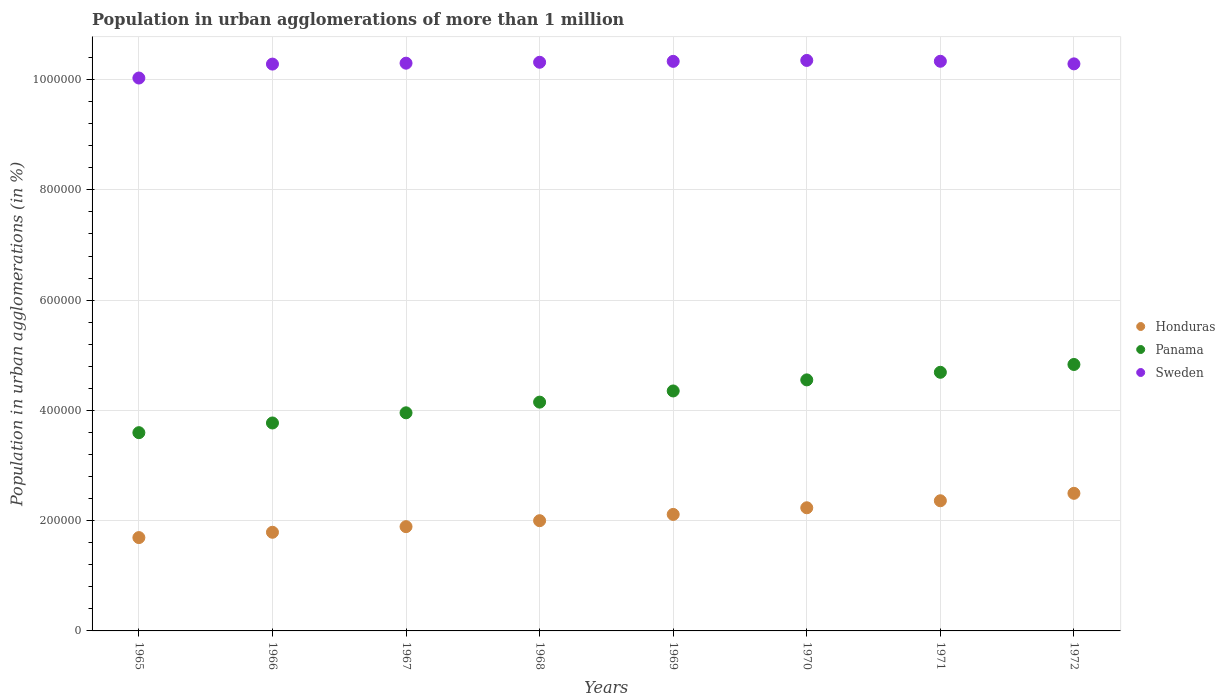What is the population in urban agglomerations in Sweden in 1967?
Offer a very short reply. 1.03e+06. Across all years, what is the maximum population in urban agglomerations in Honduras?
Your answer should be very brief. 2.50e+05. Across all years, what is the minimum population in urban agglomerations in Sweden?
Offer a very short reply. 1.00e+06. In which year was the population in urban agglomerations in Honduras minimum?
Give a very brief answer. 1965. What is the total population in urban agglomerations in Honduras in the graph?
Provide a succinct answer. 1.66e+06. What is the difference between the population in urban agglomerations in Sweden in 1965 and that in 1972?
Your answer should be compact. -2.57e+04. What is the difference between the population in urban agglomerations in Panama in 1969 and the population in urban agglomerations in Honduras in 1968?
Make the answer very short. 2.35e+05. What is the average population in urban agglomerations in Sweden per year?
Offer a terse response. 1.03e+06. In the year 1972, what is the difference between the population in urban agglomerations in Sweden and population in urban agglomerations in Panama?
Ensure brevity in your answer.  5.45e+05. In how many years, is the population in urban agglomerations in Honduras greater than 120000 %?
Provide a short and direct response. 8. What is the ratio of the population in urban agglomerations in Sweden in 1966 to that in 1970?
Make the answer very short. 0.99. Is the population in urban agglomerations in Sweden in 1970 less than that in 1971?
Your answer should be very brief. No. What is the difference between the highest and the second highest population in urban agglomerations in Panama?
Your answer should be very brief. 1.42e+04. What is the difference between the highest and the lowest population in urban agglomerations in Sweden?
Provide a short and direct response. 3.19e+04. Is the sum of the population in urban agglomerations in Honduras in 1967 and 1971 greater than the maximum population in urban agglomerations in Sweden across all years?
Your answer should be compact. No. Is it the case that in every year, the sum of the population in urban agglomerations in Sweden and population in urban agglomerations in Panama  is greater than the population in urban agglomerations in Honduras?
Give a very brief answer. Yes. Is the population in urban agglomerations in Honduras strictly greater than the population in urban agglomerations in Panama over the years?
Your answer should be compact. No. Is the population in urban agglomerations in Panama strictly less than the population in urban agglomerations in Sweden over the years?
Offer a terse response. Yes. What is the difference between two consecutive major ticks on the Y-axis?
Your response must be concise. 2.00e+05. Does the graph contain grids?
Ensure brevity in your answer.  Yes. Where does the legend appear in the graph?
Your response must be concise. Center right. How many legend labels are there?
Keep it short and to the point. 3. How are the legend labels stacked?
Provide a succinct answer. Vertical. What is the title of the graph?
Ensure brevity in your answer.  Population in urban agglomerations of more than 1 million. What is the label or title of the Y-axis?
Ensure brevity in your answer.  Population in urban agglomerations (in %). What is the Population in urban agglomerations (in %) of Honduras in 1965?
Make the answer very short. 1.69e+05. What is the Population in urban agglomerations (in %) in Panama in 1965?
Give a very brief answer. 3.60e+05. What is the Population in urban agglomerations (in %) in Sweden in 1965?
Offer a terse response. 1.00e+06. What is the Population in urban agglomerations (in %) of Honduras in 1966?
Ensure brevity in your answer.  1.79e+05. What is the Population in urban agglomerations (in %) of Panama in 1966?
Offer a terse response. 3.77e+05. What is the Population in urban agglomerations (in %) in Sweden in 1966?
Your answer should be very brief. 1.03e+06. What is the Population in urban agglomerations (in %) of Honduras in 1967?
Give a very brief answer. 1.89e+05. What is the Population in urban agglomerations (in %) of Panama in 1967?
Keep it short and to the point. 3.96e+05. What is the Population in urban agglomerations (in %) in Sweden in 1967?
Your answer should be compact. 1.03e+06. What is the Population in urban agglomerations (in %) in Honduras in 1968?
Give a very brief answer. 2.00e+05. What is the Population in urban agglomerations (in %) in Panama in 1968?
Provide a succinct answer. 4.15e+05. What is the Population in urban agglomerations (in %) in Sweden in 1968?
Provide a short and direct response. 1.03e+06. What is the Population in urban agglomerations (in %) in Honduras in 1969?
Your response must be concise. 2.11e+05. What is the Population in urban agglomerations (in %) in Panama in 1969?
Make the answer very short. 4.35e+05. What is the Population in urban agglomerations (in %) of Sweden in 1969?
Offer a very short reply. 1.03e+06. What is the Population in urban agglomerations (in %) of Honduras in 1970?
Ensure brevity in your answer.  2.23e+05. What is the Population in urban agglomerations (in %) of Panama in 1970?
Offer a terse response. 4.55e+05. What is the Population in urban agglomerations (in %) in Sweden in 1970?
Keep it short and to the point. 1.03e+06. What is the Population in urban agglomerations (in %) of Honduras in 1971?
Keep it short and to the point. 2.36e+05. What is the Population in urban agglomerations (in %) in Panama in 1971?
Give a very brief answer. 4.69e+05. What is the Population in urban agglomerations (in %) of Sweden in 1971?
Your response must be concise. 1.03e+06. What is the Population in urban agglomerations (in %) of Honduras in 1972?
Give a very brief answer. 2.50e+05. What is the Population in urban agglomerations (in %) in Panama in 1972?
Keep it short and to the point. 4.83e+05. What is the Population in urban agglomerations (in %) in Sweden in 1972?
Your answer should be very brief. 1.03e+06. Across all years, what is the maximum Population in urban agglomerations (in %) in Honduras?
Keep it short and to the point. 2.50e+05. Across all years, what is the maximum Population in urban agglomerations (in %) in Panama?
Your answer should be compact. 4.83e+05. Across all years, what is the maximum Population in urban agglomerations (in %) in Sweden?
Ensure brevity in your answer.  1.03e+06. Across all years, what is the minimum Population in urban agglomerations (in %) in Honduras?
Your response must be concise. 1.69e+05. Across all years, what is the minimum Population in urban agglomerations (in %) of Panama?
Offer a terse response. 3.60e+05. Across all years, what is the minimum Population in urban agglomerations (in %) in Sweden?
Offer a terse response. 1.00e+06. What is the total Population in urban agglomerations (in %) in Honduras in the graph?
Provide a short and direct response. 1.66e+06. What is the total Population in urban agglomerations (in %) of Panama in the graph?
Offer a terse response. 3.39e+06. What is the total Population in urban agglomerations (in %) of Sweden in the graph?
Your answer should be very brief. 8.22e+06. What is the difference between the Population in urban agglomerations (in %) of Honduras in 1965 and that in 1966?
Make the answer very short. -9649. What is the difference between the Population in urban agglomerations (in %) of Panama in 1965 and that in 1966?
Your answer should be compact. -1.76e+04. What is the difference between the Population in urban agglomerations (in %) of Sweden in 1965 and that in 1966?
Provide a short and direct response. -2.53e+04. What is the difference between the Population in urban agglomerations (in %) in Honduras in 1965 and that in 1967?
Make the answer very short. -1.98e+04. What is the difference between the Population in urban agglomerations (in %) in Panama in 1965 and that in 1967?
Your response must be concise. -3.60e+04. What is the difference between the Population in urban agglomerations (in %) of Sweden in 1965 and that in 1967?
Make the answer very short. -2.69e+04. What is the difference between the Population in urban agglomerations (in %) of Honduras in 1965 and that in 1968?
Your answer should be very brief. -3.06e+04. What is the difference between the Population in urban agglomerations (in %) in Panama in 1965 and that in 1968?
Offer a terse response. -5.54e+04. What is the difference between the Population in urban agglomerations (in %) of Sweden in 1965 and that in 1968?
Your answer should be very brief. -2.86e+04. What is the difference between the Population in urban agglomerations (in %) of Honduras in 1965 and that in 1969?
Your response must be concise. -4.20e+04. What is the difference between the Population in urban agglomerations (in %) of Panama in 1965 and that in 1969?
Your answer should be very brief. -7.57e+04. What is the difference between the Population in urban agglomerations (in %) in Sweden in 1965 and that in 1969?
Keep it short and to the point. -3.02e+04. What is the difference between the Population in urban agglomerations (in %) in Honduras in 1965 and that in 1970?
Offer a very short reply. -5.41e+04. What is the difference between the Population in urban agglomerations (in %) of Panama in 1965 and that in 1970?
Keep it short and to the point. -9.58e+04. What is the difference between the Population in urban agglomerations (in %) in Sweden in 1965 and that in 1970?
Offer a terse response. -3.19e+04. What is the difference between the Population in urban agglomerations (in %) in Honduras in 1965 and that in 1971?
Provide a succinct answer. -6.68e+04. What is the difference between the Population in urban agglomerations (in %) in Panama in 1965 and that in 1971?
Provide a short and direct response. -1.10e+05. What is the difference between the Population in urban agglomerations (in %) of Sweden in 1965 and that in 1971?
Your answer should be very brief. -3.04e+04. What is the difference between the Population in urban agglomerations (in %) in Honduras in 1965 and that in 1972?
Your response must be concise. -8.03e+04. What is the difference between the Population in urban agglomerations (in %) in Panama in 1965 and that in 1972?
Make the answer very short. -1.24e+05. What is the difference between the Population in urban agglomerations (in %) of Sweden in 1965 and that in 1972?
Provide a succinct answer. -2.57e+04. What is the difference between the Population in urban agglomerations (in %) of Honduras in 1966 and that in 1967?
Make the answer very short. -1.02e+04. What is the difference between the Population in urban agglomerations (in %) of Panama in 1966 and that in 1967?
Your answer should be very brief. -1.84e+04. What is the difference between the Population in urban agglomerations (in %) of Sweden in 1966 and that in 1967?
Give a very brief answer. -1655. What is the difference between the Population in urban agglomerations (in %) in Honduras in 1966 and that in 1968?
Offer a very short reply. -2.10e+04. What is the difference between the Population in urban agglomerations (in %) of Panama in 1966 and that in 1968?
Offer a terse response. -3.78e+04. What is the difference between the Population in urban agglomerations (in %) in Sweden in 1966 and that in 1968?
Make the answer very short. -3316. What is the difference between the Population in urban agglomerations (in %) in Honduras in 1966 and that in 1969?
Make the answer very short. -3.24e+04. What is the difference between the Population in urban agglomerations (in %) in Panama in 1966 and that in 1969?
Make the answer very short. -5.81e+04. What is the difference between the Population in urban agglomerations (in %) of Sweden in 1966 and that in 1969?
Ensure brevity in your answer.  -4974. What is the difference between the Population in urban agglomerations (in %) in Honduras in 1966 and that in 1970?
Provide a succinct answer. -4.44e+04. What is the difference between the Population in urban agglomerations (in %) of Panama in 1966 and that in 1970?
Offer a very short reply. -7.82e+04. What is the difference between the Population in urban agglomerations (in %) in Sweden in 1966 and that in 1970?
Your answer should be compact. -6638. What is the difference between the Population in urban agglomerations (in %) in Honduras in 1966 and that in 1971?
Keep it short and to the point. -5.72e+04. What is the difference between the Population in urban agglomerations (in %) of Panama in 1966 and that in 1971?
Give a very brief answer. -9.19e+04. What is the difference between the Population in urban agglomerations (in %) of Sweden in 1966 and that in 1971?
Provide a succinct answer. -5123. What is the difference between the Population in urban agglomerations (in %) of Honduras in 1966 and that in 1972?
Your response must be concise. -7.06e+04. What is the difference between the Population in urban agglomerations (in %) in Panama in 1966 and that in 1972?
Provide a short and direct response. -1.06e+05. What is the difference between the Population in urban agglomerations (in %) of Sweden in 1966 and that in 1972?
Provide a short and direct response. -418. What is the difference between the Population in urban agglomerations (in %) in Honduras in 1967 and that in 1968?
Provide a succinct answer. -1.08e+04. What is the difference between the Population in urban agglomerations (in %) in Panama in 1967 and that in 1968?
Offer a terse response. -1.94e+04. What is the difference between the Population in urban agglomerations (in %) in Sweden in 1967 and that in 1968?
Make the answer very short. -1661. What is the difference between the Population in urban agglomerations (in %) in Honduras in 1967 and that in 1969?
Offer a very short reply. -2.22e+04. What is the difference between the Population in urban agglomerations (in %) of Panama in 1967 and that in 1969?
Provide a short and direct response. -3.96e+04. What is the difference between the Population in urban agglomerations (in %) in Sweden in 1967 and that in 1969?
Ensure brevity in your answer.  -3319. What is the difference between the Population in urban agglomerations (in %) of Honduras in 1967 and that in 1970?
Your answer should be very brief. -3.42e+04. What is the difference between the Population in urban agglomerations (in %) in Panama in 1967 and that in 1970?
Keep it short and to the point. -5.97e+04. What is the difference between the Population in urban agglomerations (in %) of Sweden in 1967 and that in 1970?
Your response must be concise. -4983. What is the difference between the Population in urban agglomerations (in %) in Honduras in 1967 and that in 1971?
Your response must be concise. -4.70e+04. What is the difference between the Population in urban agglomerations (in %) in Panama in 1967 and that in 1971?
Provide a succinct answer. -7.35e+04. What is the difference between the Population in urban agglomerations (in %) in Sweden in 1967 and that in 1971?
Offer a very short reply. -3468. What is the difference between the Population in urban agglomerations (in %) of Honduras in 1967 and that in 1972?
Offer a very short reply. -6.04e+04. What is the difference between the Population in urban agglomerations (in %) in Panama in 1967 and that in 1972?
Provide a succinct answer. -8.77e+04. What is the difference between the Population in urban agglomerations (in %) of Sweden in 1967 and that in 1972?
Ensure brevity in your answer.  1237. What is the difference between the Population in urban agglomerations (in %) of Honduras in 1968 and that in 1969?
Give a very brief answer. -1.14e+04. What is the difference between the Population in urban agglomerations (in %) in Panama in 1968 and that in 1969?
Offer a very short reply. -2.03e+04. What is the difference between the Population in urban agglomerations (in %) in Sweden in 1968 and that in 1969?
Your response must be concise. -1658. What is the difference between the Population in urban agglomerations (in %) of Honduras in 1968 and that in 1970?
Ensure brevity in your answer.  -2.34e+04. What is the difference between the Population in urban agglomerations (in %) in Panama in 1968 and that in 1970?
Provide a succinct answer. -4.04e+04. What is the difference between the Population in urban agglomerations (in %) of Sweden in 1968 and that in 1970?
Make the answer very short. -3322. What is the difference between the Population in urban agglomerations (in %) in Honduras in 1968 and that in 1971?
Offer a terse response. -3.62e+04. What is the difference between the Population in urban agglomerations (in %) of Panama in 1968 and that in 1971?
Keep it short and to the point. -5.41e+04. What is the difference between the Population in urban agglomerations (in %) in Sweden in 1968 and that in 1971?
Give a very brief answer. -1807. What is the difference between the Population in urban agglomerations (in %) in Honduras in 1968 and that in 1972?
Give a very brief answer. -4.96e+04. What is the difference between the Population in urban agglomerations (in %) of Panama in 1968 and that in 1972?
Offer a very short reply. -6.83e+04. What is the difference between the Population in urban agglomerations (in %) in Sweden in 1968 and that in 1972?
Provide a short and direct response. 2898. What is the difference between the Population in urban agglomerations (in %) of Honduras in 1969 and that in 1970?
Offer a terse response. -1.20e+04. What is the difference between the Population in urban agglomerations (in %) of Panama in 1969 and that in 1970?
Your response must be concise. -2.01e+04. What is the difference between the Population in urban agglomerations (in %) of Sweden in 1969 and that in 1970?
Provide a succinct answer. -1664. What is the difference between the Population in urban agglomerations (in %) in Honduras in 1969 and that in 1971?
Offer a terse response. -2.48e+04. What is the difference between the Population in urban agglomerations (in %) of Panama in 1969 and that in 1971?
Offer a very short reply. -3.39e+04. What is the difference between the Population in urban agglomerations (in %) in Sweden in 1969 and that in 1971?
Keep it short and to the point. -149. What is the difference between the Population in urban agglomerations (in %) of Honduras in 1969 and that in 1972?
Offer a very short reply. -3.83e+04. What is the difference between the Population in urban agglomerations (in %) of Panama in 1969 and that in 1972?
Your answer should be very brief. -4.80e+04. What is the difference between the Population in urban agglomerations (in %) in Sweden in 1969 and that in 1972?
Provide a short and direct response. 4556. What is the difference between the Population in urban agglomerations (in %) in Honduras in 1970 and that in 1971?
Offer a very short reply. -1.27e+04. What is the difference between the Population in urban agglomerations (in %) of Panama in 1970 and that in 1971?
Your answer should be very brief. -1.37e+04. What is the difference between the Population in urban agglomerations (in %) in Sweden in 1970 and that in 1971?
Ensure brevity in your answer.  1515. What is the difference between the Population in urban agglomerations (in %) in Honduras in 1970 and that in 1972?
Your answer should be compact. -2.62e+04. What is the difference between the Population in urban agglomerations (in %) of Panama in 1970 and that in 1972?
Offer a very short reply. -2.79e+04. What is the difference between the Population in urban agglomerations (in %) of Sweden in 1970 and that in 1972?
Your answer should be compact. 6220. What is the difference between the Population in urban agglomerations (in %) in Honduras in 1971 and that in 1972?
Your response must be concise. -1.35e+04. What is the difference between the Population in urban agglomerations (in %) of Panama in 1971 and that in 1972?
Keep it short and to the point. -1.42e+04. What is the difference between the Population in urban agglomerations (in %) in Sweden in 1971 and that in 1972?
Keep it short and to the point. 4705. What is the difference between the Population in urban agglomerations (in %) of Honduras in 1965 and the Population in urban agglomerations (in %) of Panama in 1966?
Provide a short and direct response. -2.08e+05. What is the difference between the Population in urban agglomerations (in %) in Honduras in 1965 and the Population in urban agglomerations (in %) in Sweden in 1966?
Your response must be concise. -8.59e+05. What is the difference between the Population in urban agglomerations (in %) in Panama in 1965 and the Population in urban agglomerations (in %) in Sweden in 1966?
Give a very brief answer. -6.69e+05. What is the difference between the Population in urban agglomerations (in %) of Honduras in 1965 and the Population in urban agglomerations (in %) of Panama in 1967?
Provide a short and direct response. -2.26e+05. What is the difference between the Population in urban agglomerations (in %) of Honduras in 1965 and the Population in urban agglomerations (in %) of Sweden in 1967?
Make the answer very short. -8.60e+05. What is the difference between the Population in urban agglomerations (in %) of Panama in 1965 and the Population in urban agglomerations (in %) of Sweden in 1967?
Make the answer very short. -6.70e+05. What is the difference between the Population in urban agglomerations (in %) in Honduras in 1965 and the Population in urban agglomerations (in %) in Panama in 1968?
Provide a short and direct response. -2.46e+05. What is the difference between the Population in urban agglomerations (in %) of Honduras in 1965 and the Population in urban agglomerations (in %) of Sweden in 1968?
Your answer should be compact. -8.62e+05. What is the difference between the Population in urban agglomerations (in %) of Panama in 1965 and the Population in urban agglomerations (in %) of Sweden in 1968?
Offer a terse response. -6.72e+05. What is the difference between the Population in urban agglomerations (in %) in Honduras in 1965 and the Population in urban agglomerations (in %) in Panama in 1969?
Your response must be concise. -2.66e+05. What is the difference between the Population in urban agglomerations (in %) in Honduras in 1965 and the Population in urban agglomerations (in %) in Sweden in 1969?
Offer a very short reply. -8.64e+05. What is the difference between the Population in urban agglomerations (in %) of Panama in 1965 and the Population in urban agglomerations (in %) of Sweden in 1969?
Provide a succinct answer. -6.73e+05. What is the difference between the Population in urban agglomerations (in %) of Honduras in 1965 and the Population in urban agglomerations (in %) of Panama in 1970?
Your response must be concise. -2.86e+05. What is the difference between the Population in urban agglomerations (in %) of Honduras in 1965 and the Population in urban agglomerations (in %) of Sweden in 1970?
Give a very brief answer. -8.65e+05. What is the difference between the Population in urban agglomerations (in %) in Panama in 1965 and the Population in urban agglomerations (in %) in Sweden in 1970?
Your answer should be very brief. -6.75e+05. What is the difference between the Population in urban agglomerations (in %) of Honduras in 1965 and the Population in urban agglomerations (in %) of Panama in 1971?
Offer a very short reply. -3.00e+05. What is the difference between the Population in urban agglomerations (in %) of Honduras in 1965 and the Population in urban agglomerations (in %) of Sweden in 1971?
Ensure brevity in your answer.  -8.64e+05. What is the difference between the Population in urban agglomerations (in %) of Panama in 1965 and the Population in urban agglomerations (in %) of Sweden in 1971?
Offer a very short reply. -6.74e+05. What is the difference between the Population in urban agglomerations (in %) in Honduras in 1965 and the Population in urban agglomerations (in %) in Panama in 1972?
Provide a short and direct response. -3.14e+05. What is the difference between the Population in urban agglomerations (in %) of Honduras in 1965 and the Population in urban agglomerations (in %) of Sweden in 1972?
Give a very brief answer. -8.59e+05. What is the difference between the Population in urban agglomerations (in %) in Panama in 1965 and the Population in urban agglomerations (in %) in Sweden in 1972?
Offer a terse response. -6.69e+05. What is the difference between the Population in urban agglomerations (in %) in Honduras in 1966 and the Population in urban agglomerations (in %) in Panama in 1967?
Offer a terse response. -2.17e+05. What is the difference between the Population in urban agglomerations (in %) of Honduras in 1966 and the Population in urban agglomerations (in %) of Sweden in 1967?
Your answer should be compact. -8.51e+05. What is the difference between the Population in urban agglomerations (in %) in Panama in 1966 and the Population in urban agglomerations (in %) in Sweden in 1967?
Your answer should be compact. -6.53e+05. What is the difference between the Population in urban agglomerations (in %) in Honduras in 1966 and the Population in urban agglomerations (in %) in Panama in 1968?
Offer a terse response. -2.36e+05. What is the difference between the Population in urban agglomerations (in %) in Honduras in 1966 and the Population in urban agglomerations (in %) in Sweden in 1968?
Offer a terse response. -8.52e+05. What is the difference between the Population in urban agglomerations (in %) in Panama in 1966 and the Population in urban agglomerations (in %) in Sweden in 1968?
Make the answer very short. -6.54e+05. What is the difference between the Population in urban agglomerations (in %) of Honduras in 1966 and the Population in urban agglomerations (in %) of Panama in 1969?
Your answer should be compact. -2.56e+05. What is the difference between the Population in urban agglomerations (in %) in Honduras in 1966 and the Population in urban agglomerations (in %) in Sweden in 1969?
Make the answer very short. -8.54e+05. What is the difference between the Population in urban agglomerations (in %) in Panama in 1966 and the Population in urban agglomerations (in %) in Sweden in 1969?
Make the answer very short. -6.56e+05. What is the difference between the Population in urban agglomerations (in %) of Honduras in 1966 and the Population in urban agglomerations (in %) of Panama in 1970?
Offer a very short reply. -2.76e+05. What is the difference between the Population in urban agglomerations (in %) in Honduras in 1966 and the Population in urban agglomerations (in %) in Sweden in 1970?
Offer a terse response. -8.56e+05. What is the difference between the Population in urban agglomerations (in %) of Panama in 1966 and the Population in urban agglomerations (in %) of Sweden in 1970?
Offer a terse response. -6.58e+05. What is the difference between the Population in urban agglomerations (in %) in Honduras in 1966 and the Population in urban agglomerations (in %) in Panama in 1971?
Give a very brief answer. -2.90e+05. What is the difference between the Population in urban agglomerations (in %) in Honduras in 1966 and the Population in urban agglomerations (in %) in Sweden in 1971?
Give a very brief answer. -8.54e+05. What is the difference between the Population in urban agglomerations (in %) of Panama in 1966 and the Population in urban agglomerations (in %) of Sweden in 1971?
Your response must be concise. -6.56e+05. What is the difference between the Population in urban agglomerations (in %) in Honduras in 1966 and the Population in urban agglomerations (in %) in Panama in 1972?
Give a very brief answer. -3.04e+05. What is the difference between the Population in urban agglomerations (in %) in Honduras in 1966 and the Population in urban agglomerations (in %) in Sweden in 1972?
Keep it short and to the point. -8.50e+05. What is the difference between the Population in urban agglomerations (in %) of Panama in 1966 and the Population in urban agglomerations (in %) of Sweden in 1972?
Your response must be concise. -6.51e+05. What is the difference between the Population in urban agglomerations (in %) of Honduras in 1967 and the Population in urban agglomerations (in %) of Panama in 1968?
Provide a short and direct response. -2.26e+05. What is the difference between the Population in urban agglomerations (in %) of Honduras in 1967 and the Population in urban agglomerations (in %) of Sweden in 1968?
Your response must be concise. -8.42e+05. What is the difference between the Population in urban agglomerations (in %) in Panama in 1967 and the Population in urban agglomerations (in %) in Sweden in 1968?
Provide a succinct answer. -6.36e+05. What is the difference between the Population in urban agglomerations (in %) of Honduras in 1967 and the Population in urban agglomerations (in %) of Panama in 1969?
Provide a succinct answer. -2.46e+05. What is the difference between the Population in urban agglomerations (in %) of Honduras in 1967 and the Population in urban agglomerations (in %) of Sweden in 1969?
Provide a short and direct response. -8.44e+05. What is the difference between the Population in urban agglomerations (in %) in Panama in 1967 and the Population in urban agglomerations (in %) in Sweden in 1969?
Your answer should be compact. -6.37e+05. What is the difference between the Population in urban agglomerations (in %) in Honduras in 1967 and the Population in urban agglomerations (in %) in Panama in 1970?
Ensure brevity in your answer.  -2.66e+05. What is the difference between the Population in urban agglomerations (in %) in Honduras in 1967 and the Population in urban agglomerations (in %) in Sweden in 1970?
Make the answer very short. -8.46e+05. What is the difference between the Population in urban agglomerations (in %) in Panama in 1967 and the Population in urban agglomerations (in %) in Sweden in 1970?
Give a very brief answer. -6.39e+05. What is the difference between the Population in urban agglomerations (in %) of Honduras in 1967 and the Population in urban agglomerations (in %) of Panama in 1971?
Offer a terse response. -2.80e+05. What is the difference between the Population in urban agglomerations (in %) of Honduras in 1967 and the Population in urban agglomerations (in %) of Sweden in 1971?
Make the answer very short. -8.44e+05. What is the difference between the Population in urban agglomerations (in %) of Panama in 1967 and the Population in urban agglomerations (in %) of Sweden in 1971?
Your response must be concise. -6.38e+05. What is the difference between the Population in urban agglomerations (in %) of Honduras in 1967 and the Population in urban agglomerations (in %) of Panama in 1972?
Your answer should be compact. -2.94e+05. What is the difference between the Population in urban agglomerations (in %) of Honduras in 1967 and the Population in urban agglomerations (in %) of Sweden in 1972?
Your answer should be compact. -8.39e+05. What is the difference between the Population in urban agglomerations (in %) of Panama in 1967 and the Population in urban agglomerations (in %) of Sweden in 1972?
Your response must be concise. -6.33e+05. What is the difference between the Population in urban agglomerations (in %) in Honduras in 1968 and the Population in urban agglomerations (in %) in Panama in 1969?
Your response must be concise. -2.35e+05. What is the difference between the Population in urban agglomerations (in %) in Honduras in 1968 and the Population in urban agglomerations (in %) in Sweden in 1969?
Provide a short and direct response. -8.33e+05. What is the difference between the Population in urban agglomerations (in %) of Panama in 1968 and the Population in urban agglomerations (in %) of Sweden in 1969?
Offer a terse response. -6.18e+05. What is the difference between the Population in urban agglomerations (in %) of Honduras in 1968 and the Population in urban agglomerations (in %) of Panama in 1970?
Your answer should be very brief. -2.55e+05. What is the difference between the Population in urban agglomerations (in %) of Honduras in 1968 and the Population in urban agglomerations (in %) of Sweden in 1970?
Keep it short and to the point. -8.35e+05. What is the difference between the Population in urban agglomerations (in %) in Panama in 1968 and the Population in urban agglomerations (in %) in Sweden in 1970?
Make the answer very short. -6.20e+05. What is the difference between the Population in urban agglomerations (in %) in Honduras in 1968 and the Population in urban agglomerations (in %) in Panama in 1971?
Your answer should be compact. -2.69e+05. What is the difference between the Population in urban agglomerations (in %) of Honduras in 1968 and the Population in urban agglomerations (in %) of Sweden in 1971?
Your answer should be compact. -8.33e+05. What is the difference between the Population in urban agglomerations (in %) of Panama in 1968 and the Population in urban agglomerations (in %) of Sweden in 1971?
Provide a short and direct response. -6.18e+05. What is the difference between the Population in urban agglomerations (in %) of Honduras in 1968 and the Population in urban agglomerations (in %) of Panama in 1972?
Provide a short and direct response. -2.83e+05. What is the difference between the Population in urban agglomerations (in %) of Honduras in 1968 and the Population in urban agglomerations (in %) of Sweden in 1972?
Your answer should be very brief. -8.29e+05. What is the difference between the Population in urban agglomerations (in %) of Panama in 1968 and the Population in urban agglomerations (in %) of Sweden in 1972?
Offer a very short reply. -6.14e+05. What is the difference between the Population in urban agglomerations (in %) in Honduras in 1969 and the Population in urban agglomerations (in %) in Panama in 1970?
Provide a short and direct response. -2.44e+05. What is the difference between the Population in urban agglomerations (in %) of Honduras in 1969 and the Population in urban agglomerations (in %) of Sweden in 1970?
Your response must be concise. -8.23e+05. What is the difference between the Population in urban agglomerations (in %) of Panama in 1969 and the Population in urban agglomerations (in %) of Sweden in 1970?
Offer a very short reply. -5.99e+05. What is the difference between the Population in urban agglomerations (in %) in Honduras in 1969 and the Population in urban agglomerations (in %) in Panama in 1971?
Provide a short and direct response. -2.58e+05. What is the difference between the Population in urban agglomerations (in %) in Honduras in 1969 and the Population in urban agglomerations (in %) in Sweden in 1971?
Provide a succinct answer. -8.22e+05. What is the difference between the Population in urban agglomerations (in %) in Panama in 1969 and the Population in urban agglomerations (in %) in Sweden in 1971?
Provide a short and direct response. -5.98e+05. What is the difference between the Population in urban agglomerations (in %) of Honduras in 1969 and the Population in urban agglomerations (in %) of Panama in 1972?
Offer a very short reply. -2.72e+05. What is the difference between the Population in urban agglomerations (in %) in Honduras in 1969 and the Population in urban agglomerations (in %) in Sweden in 1972?
Make the answer very short. -8.17e+05. What is the difference between the Population in urban agglomerations (in %) of Panama in 1969 and the Population in urban agglomerations (in %) of Sweden in 1972?
Keep it short and to the point. -5.93e+05. What is the difference between the Population in urban agglomerations (in %) in Honduras in 1970 and the Population in urban agglomerations (in %) in Panama in 1971?
Give a very brief answer. -2.46e+05. What is the difference between the Population in urban agglomerations (in %) in Honduras in 1970 and the Population in urban agglomerations (in %) in Sweden in 1971?
Offer a terse response. -8.10e+05. What is the difference between the Population in urban agglomerations (in %) in Panama in 1970 and the Population in urban agglomerations (in %) in Sweden in 1971?
Provide a succinct answer. -5.78e+05. What is the difference between the Population in urban agglomerations (in %) in Honduras in 1970 and the Population in urban agglomerations (in %) in Panama in 1972?
Provide a short and direct response. -2.60e+05. What is the difference between the Population in urban agglomerations (in %) of Honduras in 1970 and the Population in urban agglomerations (in %) of Sweden in 1972?
Ensure brevity in your answer.  -8.05e+05. What is the difference between the Population in urban agglomerations (in %) in Panama in 1970 and the Population in urban agglomerations (in %) in Sweden in 1972?
Make the answer very short. -5.73e+05. What is the difference between the Population in urban agglomerations (in %) of Honduras in 1971 and the Population in urban agglomerations (in %) of Panama in 1972?
Your answer should be very brief. -2.47e+05. What is the difference between the Population in urban agglomerations (in %) of Honduras in 1971 and the Population in urban agglomerations (in %) of Sweden in 1972?
Make the answer very short. -7.92e+05. What is the difference between the Population in urban agglomerations (in %) in Panama in 1971 and the Population in urban agglomerations (in %) in Sweden in 1972?
Give a very brief answer. -5.59e+05. What is the average Population in urban agglomerations (in %) of Honduras per year?
Your answer should be compact. 2.07e+05. What is the average Population in urban agglomerations (in %) of Panama per year?
Make the answer very short. 4.24e+05. What is the average Population in urban agglomerations (in %) in Sweden per year?
Provide a succinct answer. 1.03e+06. In the year 1965, what is the difference between the Population in urban agglomerations (in %) in Honduras and Population in urban agglomerations (in %) in Panama?
Ensure brevity in your answer.  -1.90e+05. In the year 1965, what is the difference between the Population in urban agglomerations (in %) of Honduras and Population in urban agglomerations (in %) of Sweden?
Offer a very short reply. -8.34e+05. In the year 1965, what is the difference between the Population in urban agglomerations (in %) in Panama and Population in urban agglomerations (in %) in Sweden?
Offer a terse response. -6.43e+05. In the year 1966, what is the difference between the Population in urban agglomerations (in %) in Honduras and Population in urban agglomerations (in %) in Panama?
Give a very brief answer. -1.98e+05. In the year 1966, what is the difference between the Population in urban agglomerations (in %) in Honduras and Population in urban agglomerations (in %) in Sweden?
Provide a short and direct response. -8.49e+05. In the year 1966, what is the difference between the Population in urban agglomerations (in %) in Panama and Population in urban agglomerations (in %) in Sweden?
Offer a very short reply. -6.51e+05. In the year 1967, what is the difference between the Population in urban agglomerations (in %) of Honduras and Population in urban agglomerations (in %) of Panama?
Provide a short and direct response. -2.06e+05. In the year 1967, what is the difference between the Population in urban agglomerations (in %) of Honduras and Population in urban agglomerations (in %) of Sweden?
Keep it short and to the point. -8.41e+05. In the year 1967, what is the difference between the Population in urban agglomerations (in %) in Panama and Population in urban agglomerations (in %) in Sweden?
Offer a terse response. -6.34e+05. In the year 1968, what is the difference between the Population in urban agglomerations (in %) in Honduras and Population in urban agglomerations (in %) in Panama?
Give a very brief answer. -2.15e+05. In the year 1968, what is the difference between the Population in urban agglomerations (in %) of Honduras and Population in urban agglomerations (in %) of Sweden?
Offer a terse response. -8.31e+05. In the year 1968, what is the difference between the Population in urban agglomerations (in %) in Panama and Population in urban agglomerations (in %) in Sweden?
Ensure brevity in your answer.  -6.16e+05. In the year 1969, what is the difference between the Population in urban agglomerations (in %) in Honduras and Population in urban agglomerations (in %) in Panama?
Ensure brevity in your answer.  -2.24e+05. In the year 1969, what is the difference between the Population in urban agglomerations (in %) in Honduras and Population in urban agglomerations (in %) in Sweden?
Give a very brief answer. -8.22e+05. In the year 1969, what is the difference between the Population in urban agglomerations (in %) in Panama and Population in urban agglomerations (in %) in Sweden?
Ensure brevity in your answer.  -5.98e+05. In the year 1970, what is the difference between the Population in urban agglomerations (in %) of Honduras and Population in urban agglomerations (in %) of Panama?
Your response must be concise. -2.32e+05. In the year 1970, what is the difference between the Population in urban agglomerations (in %) of Honduras and Population in urban agglomerations (in %) of Sweden?
Provide a succinct answer. -8.11e+05. In the year 1970, what is the difference between the Population in urban agglomerations (in %) in Panama and Population in urban agglomerations (in %) in Sweden?
Give a very brief answer. -5.79e+05. In the year 1971, what is the difference between the Population in urban agglomerations (in %) in Honduras and Population in urban agglomerations (in %) in Panama?
Give a very brief answer. -2.33e+05. In the year 1971, what is the difference between the Population in urban agglomerations (in %) of Honduras and Population in urban agglomerations (in %) of Sweden?
Provide a short and direct response. -7.97e+05. In the year 1971, what is the difference between the Population in urban agglomerations (in %) of Panama and Population in urban agglomerations (in %) of Sweden?
Your response must be concise. -5.64e+05. In the year 1972, what is the difference between the Population in urban agglomerations (in %) of Honduras and Population in urban agglomerations (in %) of Panama?
Offer a very short reply. -2.34e+05. In the year 1972, what is the difference between the Population in urban agglomerations (in %) of Honduras and Population in urban agglomerations (in %) of Sweden?
Offer a terse response. -7.79e+05. In the year 1972, what is the difference between the Population in urban agglomerations (in %) in Panama and Population in urban agglomerations (in %) in Sweden?
Your answer should be compact. -5.45e+05. What is the ratio of the Population in urban agglomerations (in %) of Honduras in 1965 to that in 1966?
Provide a succinct answer. 0.95. What is the ratio of the Population in urban agglomerations (in %) of Panama in 1965 to that in 1966?
Your answer should be very brief. 0.95. What is the ratio of the Population in urban agglomerations (in %) in Sweden in 1965 to that in 1966?
Provide a short and direct response. 0.98. What is the ratio of the Population in urban agglomerations (in %) of Honduras in 1965 to that in 1967?
Your response must be concise. 0.9. What is the ratio of the Population in urban agglomerations (in %) in Panama in 1965 to that in 1967?
Provide a short and direct response. 0.91. What is the ratio of the Population in urban agglomerations (in %) of Sweden in 1965 to that in 1967?
Your answer should be very brief. 0.97. What is the ratio of the Population in urban agglomerations (in %) in Honduras in 1965 to that in 1968?
Provide a succinct answer. 0.85. What is the ratio of the Population in urban agglomerations (in %) of Panama in 1965 to that in 1968?
Provide a succinct answer. 0.87. What is the ratio of the Population in urban agglomerations (in %) of Sweden in 1965 to that in 1968?
Your answer should be very brief. 0.97. What is the ratio of the Population in urban agglomerations (in %) of Honduras in 1965 to that in 1969?
Keep it short and to the point. 0.8. What is the ratio of the Population in urban agglomerations (in %) in Panama in 1965 to that in 1969?
Your response must be concise. 0.83. What is the ratio of the Population in urban agglomerations (in %) in Sweden in 1965 to that in 1969?
Your response must be concise. 0.97. What is the ratio of the Population in urban agglomerations (in %) in Honduras in 1965 to that in 1970?
Provide a succinct answer. 0.76. What is the ratio of the Population in urban agglomerations (in %) in Panama in 1965 to that in 1970?
Make the answer very short. 0.79. What is the ratio of the Population in urban agglomerations (in %) of Sweden in 1965 to that in 1970?
Your answer should be compact. 0.97. What is the ratio of the Population in urban agglomerations (in %) in Honduras in 1965 to that in 1971?
Ensure brevity in your answer.  0.72. What is the ratio of the Population in urban agglomerations (in %) of Panama in 1965 to that in 1971?
Provide a short and direct response. 0.77. What is the ratio of the Population in urban agglomerations (in %) in Sweden in 1965 to that in 1971?
Your answer should be compact. 0.97. What is the ratio of the Population in urban agglomerations (in %) of Honduras in 1965 to that in 1972?
Make the answer very short. 0.68. What is the ratio of the Population in urban agglomerations (in %) in Panama in 1965 to that in 1972?
Provide a short and direct response. 0.74. What is the ratio of the Population in urban agglomerations (in %) in Sweden in 1965 to that in 1972?
Your response must be concise. 0.97. What is the ratio of the Population in urban agglomerations (in %) of Honduras in 1966 to that in 1967?
Provide a succinct answer. 0.95. What is the ratio of the Population in urban agglomerations (in %) in Panama in 1966 to that in 1967?
Your answer should be compact. 0.95. What is the ratio of the Population in urban agglomerations (in %) of Honduras in 1966 to that in 1968?
Offer a very short reply. 0.9. What is the ratio of the Population in urban agglomerations (in %) in Panama in 1966 to that in 1968?
Keep it short and to the point. 0.91. What is the ratio of the Population in urban agglomerations (in %) of Honduras in 1966 to that in 1969?
Your answer should be compact. 0.85. What is the ratio of the Population in urban agglomerations (in %) of Panama in 1966 to that in 1969?
Provide a succinct answer. 0.87. What is the ratio of the Population in urban agglomerations (in %) of Honduras in 1966 to that in 1970?
Your response must be concise. 0.8. What is the ratio of the Population in urban agglomerations (in %) of Panama in 1966 to that in 1970?
Provide a short and direct response. 0.83. What is the ratio of the Population in urban agglomerations (in %) in Honduras in 1966 to that in 1971?
Make the answer very short. 0.76. What is the ratio of the Population in urban agglomerations (in %) of Panama in 1966 to that in 1971?
Your answer should be compact. 0.8. What is the ratio of the Population in urban agglomerations (in %) of Sweden in 1966 to that in 1971?
Keep it short and to the point. 0.99. What is the ratio of the Population in urban agglomerations (in %) of Honduras in 1966 to that in 1972?
Ensure brevity in your answer.  0.72. What is the ratio of the Population in urban agglomerations (in %) in Panama in 1966 to that in 1972?
Provide a short and direct response. 0.78. What is the ratio of the Population in urban agglomerations (in %) of Honduras in 1967 to that in 1968?
Offer a very short reply. 0.95. What is the ratio of the Population in urban agglomerations (in %) in Panama in 1967 to that in 1968?
Make the answer very short. 0.95. What is the ratio of the Population in urban agglomerations (in %) of Honduras in 1967 to that in 1969?
Provide a short and direct response. 0.9. What is the ratio of the Population in urban agglomerations (in %) of Panama in 1967 to that in 1969?
Provide a short and direct response. 0.91. What is the ratio of the Population in urban agglomerations (in %) of Sweden in 1967 to that in 1969?
Make the answer very short. 1. What is the ratio of the Population in urban agglomerations (in %) in Honduras in 1967 to that in 1970?
Provide a short and direct response. 0.85. What is the ratio of the Population in urban agglomerations (in %) in Panama in 1967 to that in 1970?
Your answer should be very brief. 0.87. What is the ratio of the Population in urban agglomerations (in %) of Honduras in 1967 to that in 1971?
Your response must be concise. 0.8. What is the ratio of the Population in urban agglomerations (in %) in Panama in 1967 to that in 1971?
Keep it short and to the point. 0.84. What is the ratio of the Population in urban agglomerations (in %) in Honduras in 1967 to that in 1972?
Ensure brevity in your answer.  0.76. What is the ratio of the Population in urban agglomerations (in %) of Panama in 1967 to that in 1972?
Give a very brief answer. 0.82. What is the ratio of the Population in urban agglomerations (in %) of Sweden in 1967 to that in 1972?
Give a very brief answer. 1. What is the ratio of the Population in urban agglomerations (in %) in Honduras in 1968 to that in 1969?
Make the answer very short. 0.95. What is the ratio of the Population in urban agglomerations (in %) of Panama in 1968 to that in 1969?
Ensure brevity in your answer.  0.95. What is the ratio of the Population in urban agglomerations (in %) in Sweden in 1968 to that in 1969?
Provide a short and direct response. 1. What is the ratio of the Population in urban agglomerations (in %) of Honduras in 1968 to that in 1970?
Your answer should be compact. 0.9. What is the ratio of the Population in urban agglomerations (in %) of Panama in 1968 to that in 1970?
Your response must be concise. 0.91. What is the ratio of the Population in urban agglomerations (in %) of Honduras in 1968 to that in 1971?
Give a very brief answer. 0.85. What is the ratio of the Population in urban agglomerations (in %) in Panama in 1968 to that in 1971?
Ensure brevity in your answer.  0.88. What is the ratio of the Population in urban agglomerations (in %) of Honduras in 1968 to that in 1972?
Provide a succinct answer. 0.8. What is the ratio of the Population in urban agglomerations (in %) in Panama in 1968 to that in 1972?
Your response must be concise. 0.86. What is the ratio of the Population in urban agglomerations (in %) of Sweden in 1968 to that in 1972?
Give a very brief answer. 1. What is the ratio of the Population in urban agglomerations (in %) in Honduras in 1969 to that in 1970?
Keep it short and to the point. 0.95. What is the ratio of the Population in urban agglomerations (in %) in Panama in 1969 to that in 1970?
Provide a succinct answer. 0.96. What is the ratio of the Population in urban agglomerations (in %) of Honduras in 1969 to that in 1971?
Ensure brevity in your answer.  0.9. What is the ratio of the Population in urban agglomerations (in %) in Panama in 1969 to that in 1971?
Ensure brevity in your answer.  0.93. What is the ratio of the Population in urban agglomerations (in %) of Honduras in 1969 to that in 1972?
Make the answer very short. 0.85. What is the ratio of the Population in urban agglomerations (in %) in Panama in 1969 to that in 1972?
Offer a terse response. 0.9. What is the ratio of the Population in urban agglomerations (in %) in Honduras in 1970 to that in 1971?
Give a very brief answer. 0.95. What is the ratio of the Population in urban agglomerations (in %) in Panama in 1970 to that in 1971?
Make the answer very short. 0.97. What is the ratio of the Population in urban agglomerations (in %) in Sweden in 1970 to that in 1971?
Your answer should be compact. 1. What is the ratio of the Population in urban agglomerations (in %) in Honduras in 1970 to that in 1972?
Your response must be concise. 0.9. What is the ratio of the Population in urban agglomerations (in %) in Panama in 1970 to that in 1972?
Keep it short and to the point. 0.94. What is the ratio of the Population in urban agglomerations (in %) of Sweden in 1970 to that in 1972?
Keep it short and to the point. 1.01. What is the ratio of the Population in urban agglomerations (in %) in Honduras in 1971 to that in 1972?
Your response must be concise. 0.95. What is the ratio of the Population in urban agglomerations (in %) of Panama in 1971 to that in 1972?
Provide a succinct answer. 0.97. What is the difference between the highest and the second highest Population in urban agglomerations (in %) of Honduras?
Ensure brevity in your answer.  1.35e+04. What is the difference between the highest and the second highest Population in urban agglomerations (in %) in Panama?
Provide a short and direct response. 1.42e+04. What is the difference between the highest and the second highest Population in urban agglomerations (in %) in Sweden?
Your answer should be compact. 1515. What is the difference between the highest and the lowest Population in urban agglomerations (in %) of Honduras?
Your response must be concise. 8.03e+04. What is the difference between the highest and the lowest Population in urban agglomerations (in %) of Panama?
Give a very brief answer. 1.24e+05. What is the difference between the highest and the lowest Population in urban agglomerations (in %) of Sweden?
Provide a succinct answer. 3.19e+04. 